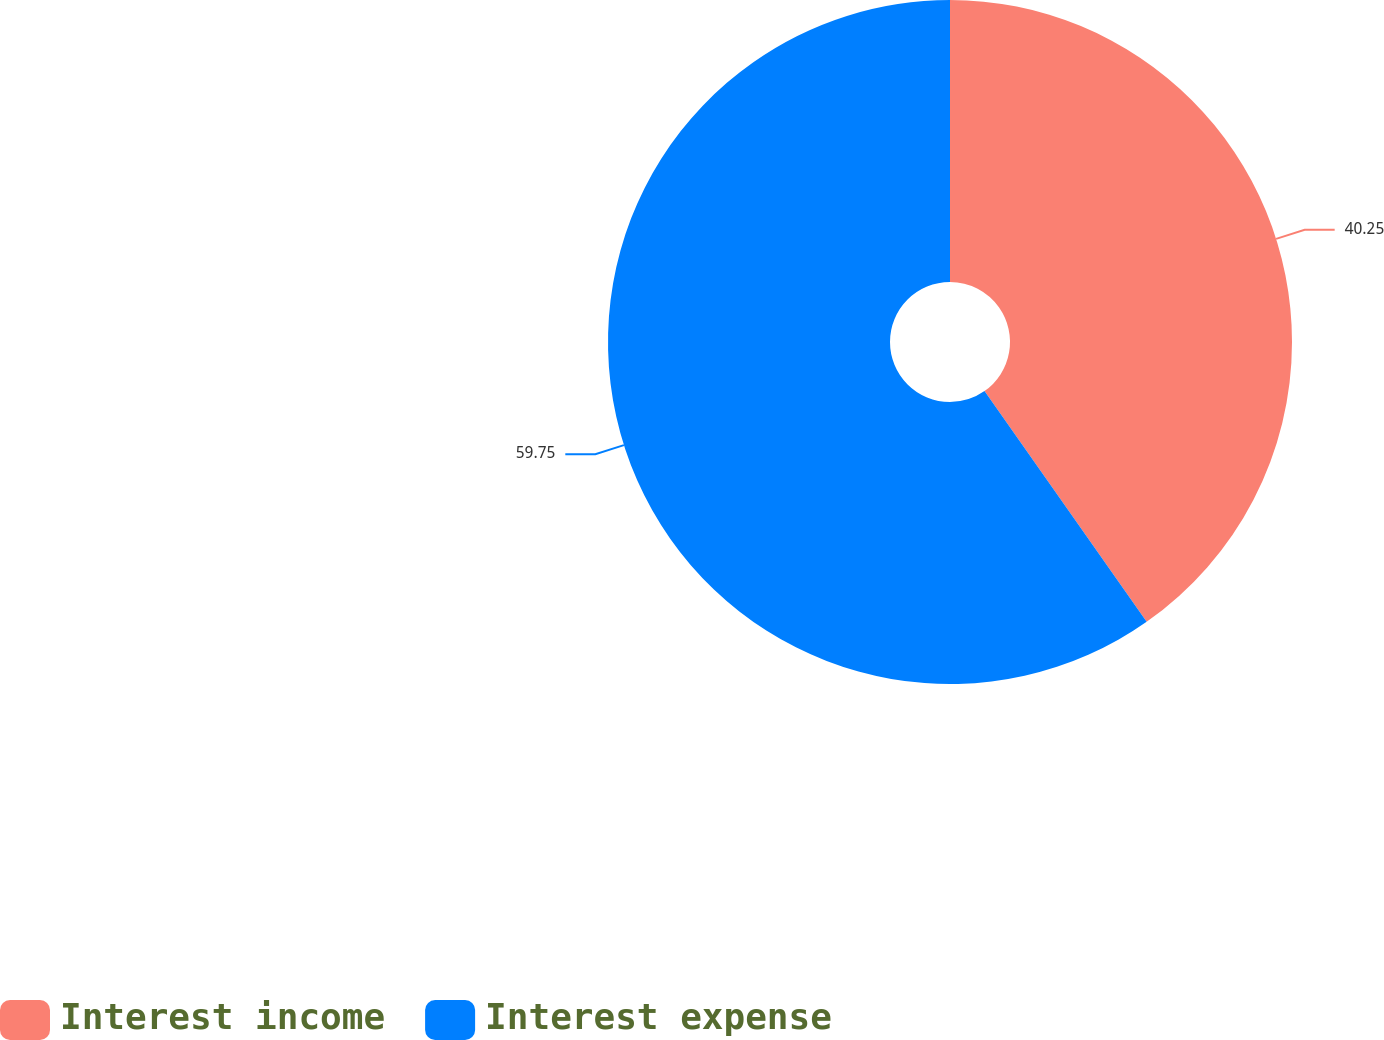<chart> <loc_0><loc_0><loc_500><loc_500><pie_chart><fcel>Interest income<fcel>Interest expense<nl><fcel>40.25%<fcel>59.75%<nl></chart> 